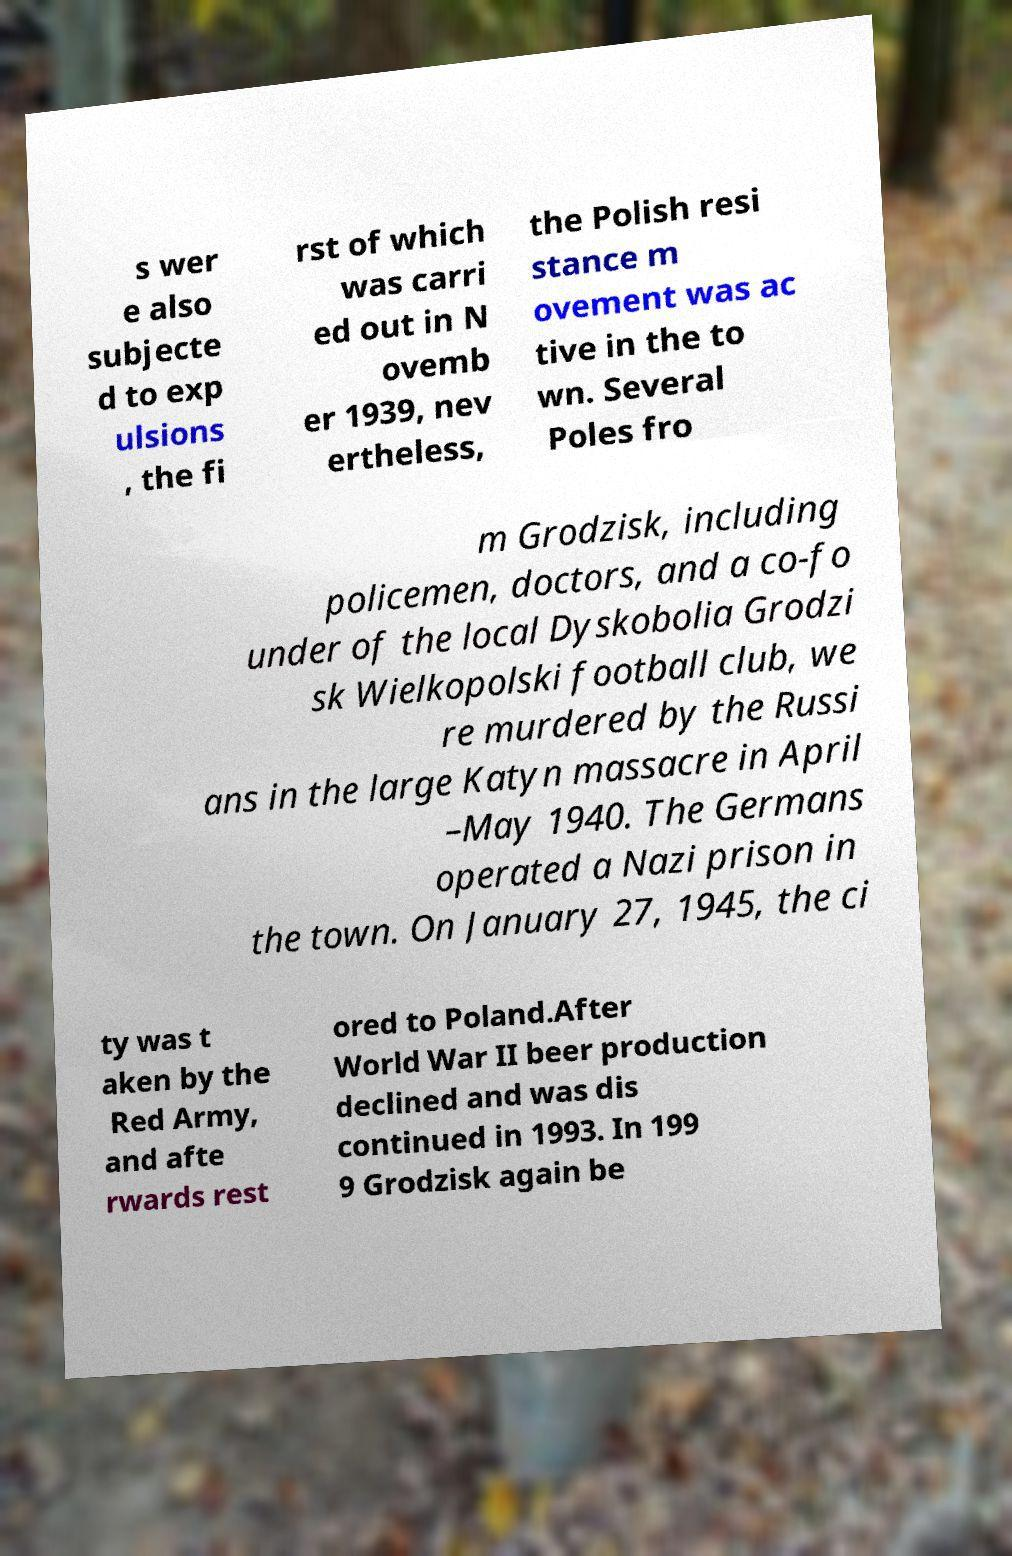Please read and relay the text visible in this image. What does it say? s wer e also subjecte d to exp ulsions , the fi rst of which was carri ed out in N ovemb er 1939, nev ertheless, the Polish resi stance m ovement was ac tive in the to wn. Several Poles fro m Grodzisk, including policemen, doctors, and a co-fo under of the local Dyskobolia Grodzi sk Wielkopolski football club, we re murdered by the Russi ans in the large Katyn massacre in April –May 1940. The Germans operated a Nazi prison in the town. On January 27, 1945, the ci ty was t aken by the Red Army, and afte rwards rest ored to Poland.After World War II beer production declined and was dis continued in 1993. In 199 9 Grodzisk again be 